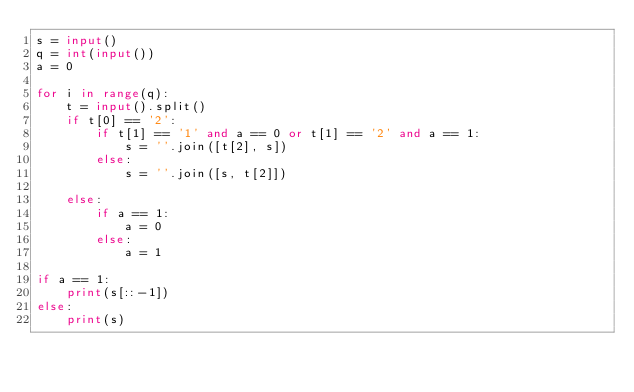Convert code to text. <code><loc_0><loc_0><loc_500><loc_500><_Python_>s = input()
q = int(input())
a = 0

for i in range(q):
    t = input().split()
    if t[0] == '2':
        if t[1] == '1' and a == 0 or t[1] == '2' and a == 1:
            s = ''.join([t[2], s])
        else:
            s = ''.join([s, t[2]])

    else:
        if a == 1:
            a = 0
        else:
            a = 1
        
if a == 1:
    print(s[::-1])
else:
    print(s)
</code> 